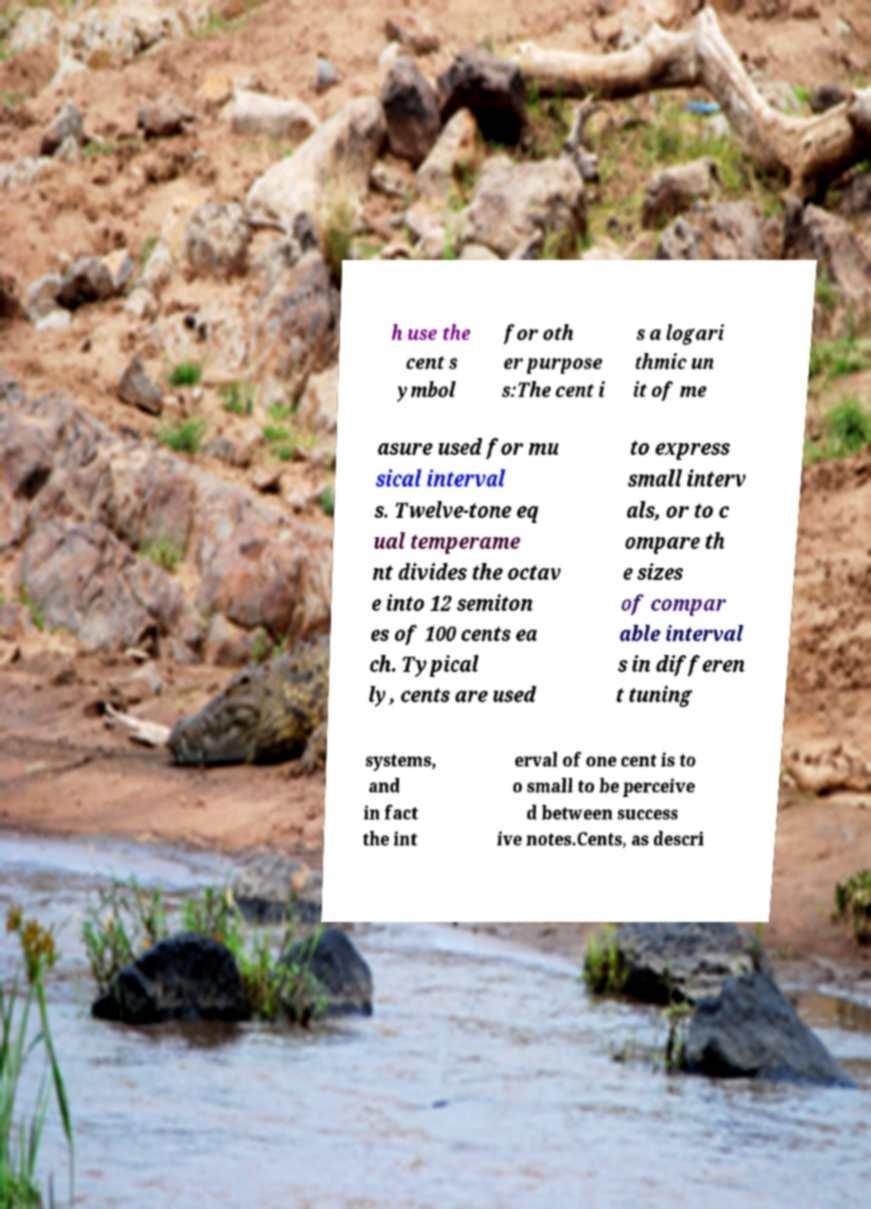For documentation purposes, I need the text within this image transcribed. Could you provide that? h use the cent s ymbol for oth er purpose s:The cent i s a logari thmic un it of me asure used for mu sical interval s. Twelve-tone eq ual temperame nt divides the octav e into 12 semiton es of 100 cents ea ch. Typical ly, cents are used to express small interv als, or to c ompare th e sizes of compar able interval s in differen t tuning systems, and in fact the int erval of one cent is to o small to be perceive d between success ive notes.Cents, as descri 